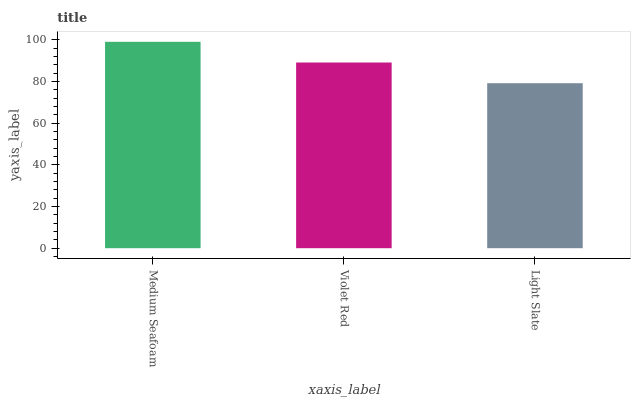Is Violet Red the minimum?
Answer yes or no. No. Is Violet Red the maximum?
Answer yes or no. No. Is Medium Seafoam greater than Violet Red?
Answer yes or no. Yes. Is Violet Red less than Medium Seafoam?
Answer yes or no. Yes. Is Violet Red greater than Medium Seafoam?
Answer yes or no. No. Is Medium Seafoam less than Violet Red?
Answer yes or no. No. Is Violet Red the high median?
Answer yes or no. Yes. Is Violet Red the low median?
Answer yes or no. Yes. Is Light Slate the high median?
Answer yes or no. No. Is Light Slate the low median?
Answer yes or no. No. 